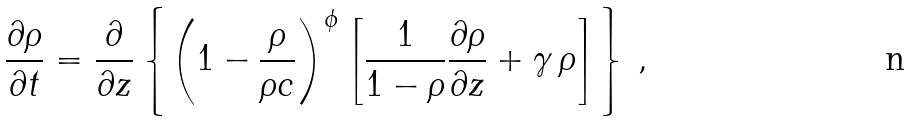<formula> <loc_0><loc_0><loc_500><loc_500>\frac { \partial \rho } { \partial t } = \frac { \partial } { \partial z } \left \{ \left ( 1 - \frac { \rho } { \rho c } \right ) ^ { \phi } \left [ \frac { 1 } { 1 - \rho } \frac { \partial \rho } { \partial z } + \gamma \, \rho \right ] \right \} \, ,</formula> 